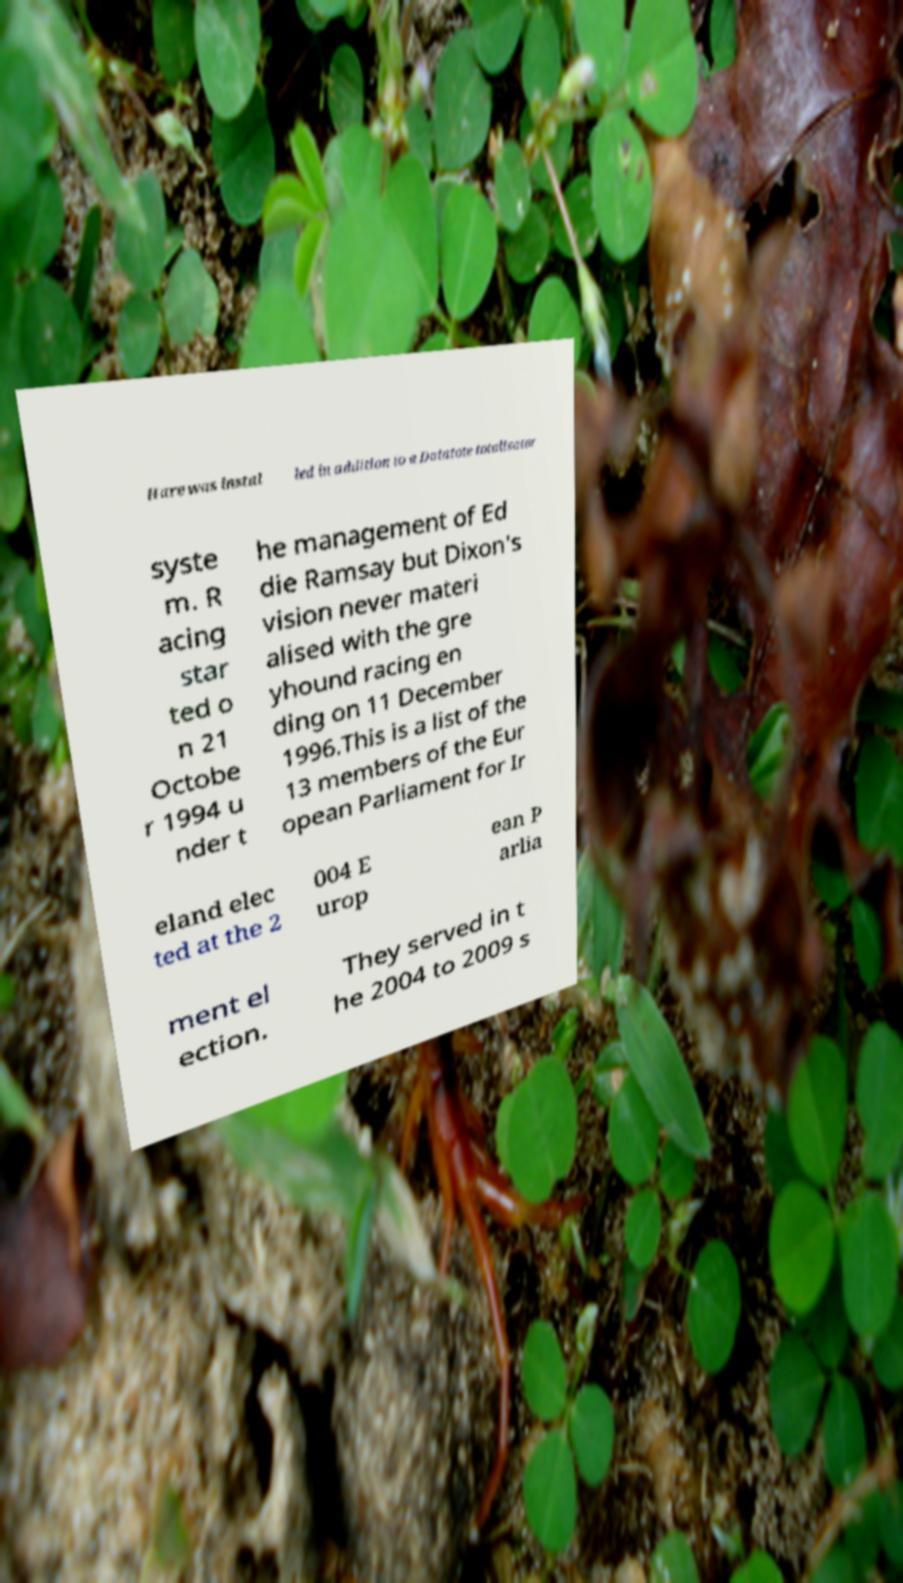Please read and relay the text visible in this image. What does it say? Hare was instal led in addition to a Datatote totalisator syste m. R acing star ted o n 21 Octobe r 1994 u nder t he management of Ed die Ramsay but Dixon's vision never materi alised with the gre yhound racing en ding on 11 December 1996.This is a list of the 13 members of the Eur opean Parliament for Ir eland elec ted at the 2 004 E urop ean P arlia ment el ection. They served in t he 2004 to 2009 s 